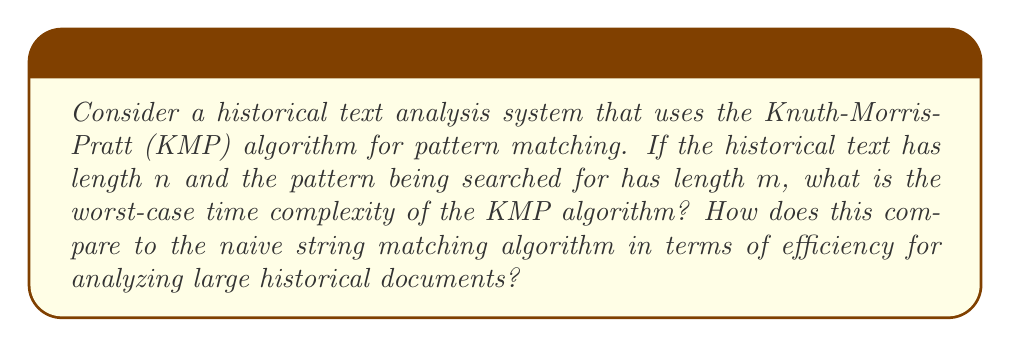Can you answer this question? To analyze the computational efficiency of the Knuth-Morris-Pratt (KMP) algorithm compared to the naive string matching algorithm, we need to consider their time complexities:

1. Naive String Matching Algorithm:
   - Worst-case time complexity: $O(nm)$
   - For each character in the text (n iterations), it potentially compares m characters.

2. Knuth-Morris-Pratt (KMP) Algorithm:
   - Preprocessing step: $O(m)$ to build the failure function
   - Main search step: $O(n)$
   - Total worst-case time complexity: $O(m + n)$

The KMP algorithm achieves this efficiency by:
a) Preprocessing the pattern to create a failure function in $O(m)$ time.
b) Using the failure function to skip unnecessary comparisons during the search phase.

For large historical documents where $n >> m$:
- Naive algorithm: $O(nm)$ ≈ $O(n)$ (but with a large constant factor m)
- KMP algorithm: $O(m + n)$ ≈ $O(n)$

The KMP algorithm is asymptotically more efficient, especially for:
1. Long texts (large n)
2. Repeated searches with the same pattern
3. Patterns with many repeated substrings

For historical text analysis, where documents can be very large and patterns may be searched multiple times, the KMP algorithm offers significant performance benefits over the naive approach.
Answer: The worst-case time complexity of the Knuth-Morris-Pratt (KMP) algorithm is $O(m + n)$, where $n$ is the length of the text and $m$ is the length of the pattern. This is more efficient than the naive string matching algorithm's $O(nm)$ worst-case time complexity, especially for analyzing large historical documents where $n$ is typically much larger than $m$. 